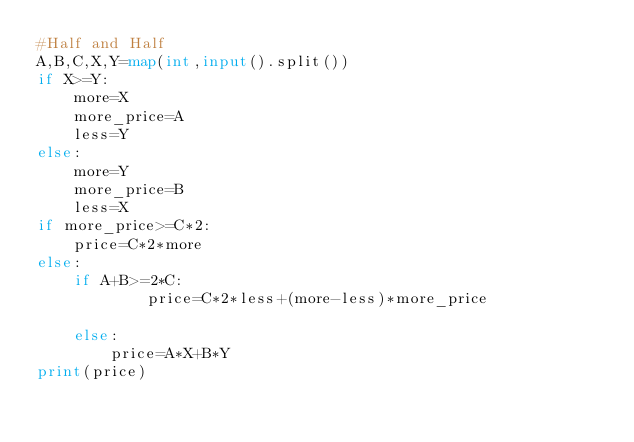<code> <loc_0><loc_0><loc_500><loc_500><_Python_>#Half and Half
A,B,C,X,Y=map(int,input().split())
if X>=Y:
    more=X
    more_price=A
    less=Y
else:
    more=Y
    more_price=B
    less=X
if more_price>=C*2:
    price=C*2*more
else:
    if A+B>=2*C:
            price=C*2*less+(more-less)*more_price
        
    else:
        price=A*X+B*Y
print(price)

</code> 